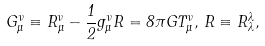<formula> <loc_0><loc_0><loc_500><loc_500>G _ { \mu } ^ { \nu } \equiv R _ { \mu } ^ { \nu } - \frac { 1 } { 2 } g _ { \mu } ^ { \nu } R = 8 \pi G T _ { \mu } ^ { \nu } , \, R \equiv R _ { \lambda } ^ { \lambda } ,</formula> 